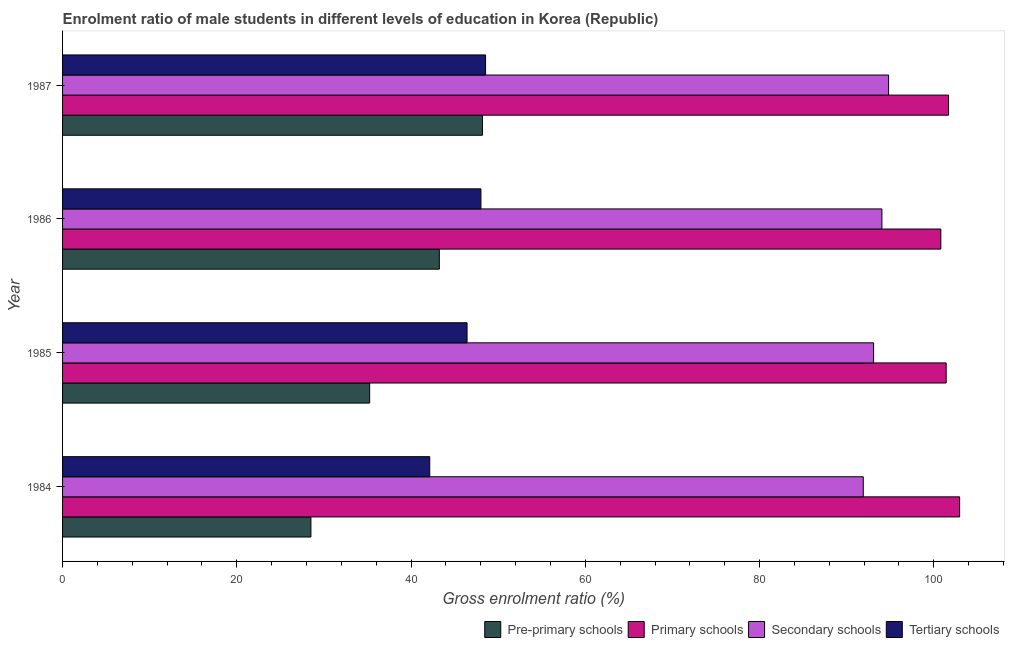How many groups of bars are there?
Give a very brief answer. 4. What is the gross enrolment ratio(female) in primary schools in 1984?
Provide a succinct answer. 102.97. Across all years, what is the maximum gross enrolment ratio(female) in secondary schools?
Provide a succinct answer. 94.81. Across all years, what is the minimum gross enrolment ratio(female) in secondary schools?
Your response must be concise. 91.91. In which year was the gross enrolment ratio(female) in tertiary schools maximum?
Give a very brief answer. 1987. What is the total gross enrolment ratio(female) in tertiary schools in the graph?
Provide a succinct answer. 185.15. What is the difference between the gross enrolment ratio(female) in secondary schools in 1985 and that in 1987?
Offer a very short reply. -1.72. What is the difference between the gross enrolment ratio(female) in primary schools in 1987 and the gross enrolment ratio(female) in secondary schools in 1984?
Your response must be concise. 9.79. What is the average gross enrolment ratio(female) in tertiary schools per year?
Give a very brief answer. 46.29. In the year 1984, what is the difference between the gross enrolment ratio(female) in primary schools and gross enrolment ratio(female) in tertiary schools?
Your answer should be very brief. 60.82. In how many years, is the gross enrolment ratio(female) in tertiary schools greater than 52 %?
Provide a short and direct response. 0. What is the ratio of the gross enrolment ratio(female) in pre-primary schools in 1985 to that in 1987?
Give a very brief answer. 0.73. Is the gross enrolment ratio(female) in pre-primary schools in 1984 less than that in 1987?
Give a very brief answer. Yes. What is the difference between the highest and the second highest gross enrolment ratio(female) in primary schools?
Your answer should be compact. 1.27. What is the difference between the highest and the lowest gross enrolment ratio(female) in primary schools?
Your answer should be compact. 2.16. In how many years, is the gross enrolment ratio(female) in pre-primary schools greater than the average gross enrolment ratio(female) in pre-primary schools taken over all years?
Offer a very short reply. 2. What does the 4th bar from the top in 1985 represents?
Make the answer very short. Pre-primary schools. What does the 2nd bar from the bottom in 1986 represents?
Keep it short and to the point. Primary schools. Is it the case that in every year, the sum of the gross enrolment ratio(female) in pre-primary schools and gross enrolment ratio(female) in primary schools is greater than the gross enrolment ratio(female) in secondary schools?
Ensure brevity in your answer.  Yes. How many bars are there?
Your answer should be very brief. 16. How many years are there in the graph?
Make the answer very short. 4. What is the difference between two consecutive major ticks on the X-axis?
Provide a succinct answer. 20. Are the values on the major ticks of X-axis written in scientific E-notation?
Offer a terse response. No. Does the graph contain any zero values?
Your answer should be compact. No. How many legend labels are there?
Ensure brevity in your answer.  4. What is the title of the graph?
Provide a succinct answer. Enrolment ratio of male students in different levels of education in Korea (Republic). What is the label or title of the Y-axis?
Your answer should be very brief. Year. What is the Gross enrolment ratio (%) of Pre-primary schools in 1984?
Provide a succinct answer. 28.51. What is the Gross enrolment ratio (%) in Primary schools in 1984?
Provide a succinct answer. 102.97. What is the Gross enrolment ratio (%) of Secondary schools in 1984?
Keep it short and to the point. 91.91. What is the Gross enrolment ratio (%) in Tertiary schools in 1984?
Your answer should be compact. 42.15. What is the Gross enrolment ratio (%) in Pre-primary schools in 1985?
Your response must be concise. 35.25. What is the Gross enrolment ratio (%) of Primary schools in 1985?
Keep it short and to the point. 101.42. What is the Gross enrolment ratio (%) of Secondary schools in 1985?
Your answer should be very brief. 93.09. What is the Gross enrolment ratio (%) of Tertiary schools in 1985?
Offer a terse response. 46.43. What is the Gross enrolment ratio (%) in Pre-primary schools in 1986?
Keep it short and to the point. 43.25. What is the Gross enrolment ratio (%) in Primary schools in 1986?
Give a very brief answer. 100.81. What is the Gross enrolment ratio (%) in Secondary schools in 1986?
Give a very brief answer. 94.04. What is the Gross enrolment ratio (%) of Tertiary schools in 1986?
Offer a terse response. 48.02. What is the Gross enrolment ratio (%) of Pre-primary schools in 1987?
Provide a short and direct response. 48.19. What is the Gross enrolment ratio (%) in Primary schools in 1987?
Your answer should be very brief. 101.69. What is the Gross enrolment ratio (%) of Secondary schools in 1987?
Keep it short and to the point. 94.81. What is the Gross enrolment ratio (%) in Tertiary schools in 1987?
Ensure brevity in your answer.  48.55. Across all years, what is the maximum Gross enrolment ratio (%) in Pre-primary schools?
Offer a terse response. 48.19. Across all years, what is the maximum Gross enrolment ratio (%) in Primary schools?
Your answer should be very brief. 102.97. Across all years, what is the maximum Gross enrolment ratio (%) of Secondary schools?
Ensure brevity in your answer.  94.81. Across all years, what is the maximum Gross enrolment ratio (%) in Tertiary schools?
Provide a succinct answer. 48.55. Across all years, what is the minimum Gross enrolment ratio (%) of Pre-primary schools?
Keep it short and to the point. 28.51. Across all years, what is the minimum Gross enrolment ratio (%) of Primary schools?
Keep it short and to the point. 100.81. Across all years, what is the minimum Gross enrolment ratio (%) in Secondary schools?
Provide a succinct answer. 91.91. Across all years, what is the minimum Gross enrolment ratio (%) in Tertiary schools?
Offer a terse response. 42.15. What is the total Gross enrolment ratio (%) in Pre-primary schools in the graph?
Provide a short and direct response. 155.2. What is the total Gross enrolment ratio (%) in Primary schools in the graph?
Keep it short and to the point. 406.89. What is the total Gross enrolment ratio (%) in Secondary schools in the graph?
Provide a short and direct response. 373.86. What is the total Gross enrolment ratio (%) of Tertiary schools in the graph?
Ensure brevity in your answer.  185.15. What is the difference between the Gross enrolment ratio (%) of Pre-primary schools in 1984 and that in 1985?
Provide a succinct answer. -6.74. What is the difference between the Gross enrolment ratio (%) in Primary schools in 1984 and that in 1985?
Your answer should be compact. 1.55. What is the difference between the Gross enrolment ratio (%) in Secondary schools in 1984 and that in 1985?
Your response must be concise. -1.19. What is the difference between the Gross enrolment ratio (%) of Tertiary schools in 1984 and that in 1985?
Give a very brief answer. -4.28. What is the difference between the Gross enrolment ratio (%) in Pre-primary schools in 1984 and that in 1986?
Offer a terse response. -14.74. What is the difference between the Gross enrolment ratio (%) of Primary schools in 1984 and that in 1986?
Your answer should be very brief. 2.16. What is the difference between the Gross enrolment ratio (%) in Secondary schools in 1984 and that in 1986?
Keep it short and to the point. -2.14. What is the difference between the Gross enrolment ratio (%) in Tertiary schools in 1984 and that in 1986?
Your response must be concise. -5.87. What is the difference between the Gross enrolment ratio (%) in Pre-primary schools in 1984 and that in 1987?
Ensure brevity in your answer.  -19.69. What is the difference between the Gross enrolment ratio (%) of Primary schools in 1984 and that in 1987?
Your response must be concise. 1.27. What is the difference between the Gross enrolment ratio (%) of Secondary schools in 1984 and that in 1987?
Your answer should be compact. -2.91. What is the difference between the Gross enrolment ratio (%) in Tertiary schools in 1984 and that in 1987?
Provide a succinct answer. -6.41. What is the difference between the Gross enrolment ratio (%) in Pre-primary schools in 1985 and that in 1986?
Your answer should be compact. -8. What is the difference between the Gross enrolment ratio (%) of Primary schools in 1985 and that in 1986?
Make the answer very short. 0.61. What is the difference between the Gross enrolment ratio (%) in Secondary schools in 1985 and that in 1986?
Your response must be concise. -0.95. What is the difference between the Gross enrolment ratio (%) of Tertiary schools in 1985 and that in 1986?
Make the answer very short. -1.59. What is the difference between the Gross enrolment ratio (%) in Pre-primary schools in 1985 and that in 1987?
Your answer should be very brief. -12.95. What is the difference between the Gross enrolment ratio (%) of Primary schools in 1985 and that in 1987?
Your answer should be very brief. -0.27. What is the difference between the Gross enrolment ratio (%) of Secondary schools in 1985 and that in 1987?
Ensure brevity in your answer.  -1.72. What is the difference between the Gross enrolment ratio (%) of Tertiary schools in 1985 and that in 1987?
Give a very brief answer. -2.12. What is the difference between the Gross enrolment ratio (%) of Pre-primary schools in 1986 and that in 1987?
Provide a short and direct response. -4.95. What is the difference between the Gross enrolment ratio (%) in Primary schools in 1986 and that in 1987?
Your response must be concise. -0.89. What is the difference between the Gross enrolment ratio (%) of Secondary schools in 1986 and that in 1987?
Give a very brief answer. -0.77. What is the difference between the Gross enrolment ratio (%) of Tertiary schools in 1986 and that in 1987?
Your answer should be very brief. -0.53. What is the difference between the Gross enrolment ratio (%) of Pre-primary schools in 1984 and the Gross enrolment ratio (%) of Primary schools in 1985?
Your answer should be compact. -72.91. What is the difference between the Gross enrolment ratio (%) in Pre-primary schools in 1984 and the Gross enrolment ratio (%) in Secondary schools in 1985?
Offer a terse response. -64.59. What is the difference between the Gross enrolment ratio (%) of Pre-primary schools in 1984 and the Gross enrolment ratio (%) of Tertiary schools in 1985?
Your answer should be compact. -17.92. What is the difference between the Gross enrolment ratio (%) of Primary schools in 1984 and the Gross enrolment ratio (%) of Secondary schools in 1985?
Give a very brief answer. 9.88. What is the difference between the Gross enrolment ratio (%) in Primary schools in 1984 and the Gross enrolment ratio (%) in Tertiary schools in 1985?
Your answer should be very brief. 56.54. What is the difference between the Gross enrolment ratio (%) of Secondary schools in 1984 and the Gross enrolment ratio (%) of Tertiary schools in 1985?
Make the answer very short. 45.48. What is the difference between the Gross enrolment ratio (%) in Pre-primary schools in 1984 and the Gross enrolment ratio (%) in Primary schools in 1986?
Your answer should be compact. -72.3. What is the difference between the Gross enrolment ratio (%) in Pre-primary schools in 1984 and the Gross enrolment ratio (%) in Secondary schools in 1986?
Keep it short and to the point. -65.54. What is the difference between the Gross enrolment ratio (%) of Pre-primary schools in 1984 and the Gross enrolment ratio (%) of Tertiary schools in 1986?
Provide a succinct answer. -19.51. What is the difference between the Gross enrolment ratio (%) of Primary schools in 1984 and the Gross enrolment ratio (%) of Secondary schools in 1986?
Your answer should be compact. 8.92. What is the difference between the Gross enrolment ratio (%) of Primary schools in 1984 and the Gross enrolment ratio (%) of Tertiary schools in 1986?
Offer a very short reply. 54.95. What is the difference between the Gross enrolment ratio (%) in Secondary schools in 1984 and the Gross enrolment ratio (%) in Tertiary schools in 1986?
Offer a very short reply. 43.89. What is the difference between the Gross enrolment ratio (%) in Pre-primary schools in 1984 and the Gross enrolment ratio (%) in Primary schools in 1987?
Provide a short and direct response. -73.19. What is the difference between the Gross enrolment ratio (%) in Pre-primary schools in 1984 and the Gross enrolment ratio (%) in Secondary schools in 1987?
Give a very brief answer. -66.31. What is the difference between the Gross enrolment ratio (%) in Pre-primary schools in 1984 and the Gross enrolment ratio (%) in Tertiary schools in 1987?
Make the answer very short. -20.05. What is the difference between the Gross enrolment ratio (%) of Primary schools in 1984 and the Gross enrolment ratio (%) of Secondary schools in 1987?
Your response must be concise. 8.15. What is the difference between the Gross enrolment ratio (%) of Primary schools in 1984 and the Gross enrolment ratio (%) of Tertiary schools in 1987?
Offer a very short reply. 54.41. What is the difference between the Gross enrolment ratio (%) in Secondary schools in 1984 and the Gross enrolment ratio (%) in Tertiary schools in 1987?
Offer a very short reply. 43.35. What is the difference between the Gross enrolment ratio (%) in Pre-primary schools in 1985 and the Gross enrolment ratio (%) in Primary schools in 1986?
Offer a very short reply. -65.56. What is the difference between the Gross enrolment ratio (%) of Pre-primary schools in 1985 and the Gross enrolment ratio (%) of Secondary schools in 1986?
Your answer should be compact. -58.8. What is the difference between the Gross enrolment ratio (%) of Pre-primary schools in 1985 and the Gross enrolment ratio (%) of Tertiary schools in 1986?
Offer a terse response. -12.77. What is the difference between the Gross enrolment ratio (%) in Primary schools in 1985 and the Gross enrolment ratio (%) in Secondary schools in 1986?
Keep it short and to the point. 7.38. What is the difference between the Gross enrolment ratio (%) of Primary schools in 1985 and the Gross enrolment ratio (%) of Tertiary schools in 1986?
Your answer should be very brief. 53.4. What is the difference between the Gross enrolment ratio (%) of Secondary schools in 1985 and the Gross enrolment ratio (%) of Tertiary schools in 1986?
Your answer should be compact. 45.07. What is the difference between the Gross enrolment ratio (%) of Pre-primary schools in 1985 and the Gross enrolment ratio (%) of Primary schools in 1987?
Your answer should be very brief. -66.44. What is the difference between the Gross enrolment ratio (%) in Pre-primary schools in 1985 and the Gross enrolment ratio (%) in Secondary schools in 1987?
Provide a short and direct response. -59.56. What is the difference between the Gross enrolment ratio (%) of Pre-primary schools in 1985 and the Gross enrolment ratio (%) of Tertiary schools in 1987?
Your answer should be compact. -13.3. What is the difference between the Gross enrolment ratio (%) of Primary schools in 1985 and the Gross enrolment ratio (%) of Secondary schools in 1987?
Keep it short and to the point. 6.61. What is the difference between the Gross enrolment ratio (%) in Primary schools in 1985 and the Gross enrolment ratio (%) in Tertiary schools in 1987?
Give a very brief answer. 52.87. What is the difference between the Gross enrolment ratio (%) of Secondary schools in 1985 and the Gross enrolment ratio (%) of Tertiary schools in 1987?
Your answer should be very brief. 44.54. What is the difference between the Gross enrolment ratio (%) in Pre-primary schools in 1986 and the Gross enrolment ratio (%) in Primary schools in 1987?
Your response must be concise. -58.45. What is the difference between the Gross enrolment ratio (%) of Pre-primary schools in 1986 and the Gross enrolment ratio (%) of Secondary schools in 1987?
Offer a terse response. -51.57. What is the difference between the Gross enrolment ratio (%) of Pre-primary schools in 1986 and the Gross enrolment ratio (%) of Tertiary schools in 1987?
Give a very brief answer. -5.31. What is the difference between the Gross enrolment ratio (%) in Primary schools in 1986 and the Gross enrolment ratio (%) in Secondary schools in 1987?
Ensure brevity in your answer.  6. What is the difference between the Gross enrolment ratio (%) in Primary schools in 1986 and the Gross enrolment ratio (%) in Tertiary schools in 1987?
Make the answer very short. 52.26. What is the difference between the Gross enrolment ratio (%) in Secondary schools in 1986 and the Gross enrolment ratio (%) in Tertiary schools in 1987?
Offer a very short reply. 45.49. What is the average Gross enrolment ratio (%) of Pre-primary schools per year?
Keep it short and to the point. 38.8. What is the average Gross enrolment ratio (%) of Primary schools per year?
Your answer should be compact. 101.72. What is the average Gross enrolment ratio (%) in Secondary schools per year?
Provide a succinct answer. 93.46. What is the average Gross enrolment ratio (%) in Tertiary schools per year?
Your answer should be very brief. 46.29. In the year 1984, what is the difference between the Gross enrolment ratio (%) in Pre-primary schools and Gross enrolment ratio (%) in Primary schools?
Give a very brief answer. -74.46. In the year 1984, what is the difference between the Gross enrolment ratio (%) of Pre-primary schools and Gross enrolment ratio (%) of Secondary schools?
Offer a very short reply. -63.4. In the year 1984, what is the difference between the Gross enrolment ratio (%) of Pre-primary schools and Gross enrolment ratio (%) of Tertiary schools?
Your response must be concise. -13.64. In the year 1984, what is the difference between the Gross enrolment ratio (%) of Primary schools and Gross enrolment ratio (%) of Secondary schools?
Your answer should be very brief. 11.06. In the year 1984, what is the difference between the Gross enrolment ratio (%) in Primary schools and Gross enrolment ratio (%) in Tertiary schools?
Make the answer very short. 60.82. In the year 1984, what is the difference between the Gross enrolment ratio (%) of Secondary schools and Gross enrolment ratio (%) of Tertiary schools?
Provide a succinct answer. 49.76. In the year 1985, what is the difference between the Gross enrolment ratio (%) in Pre-primary schools and Gross enrolment ratio (%) in Primary schools?
Offer a very short reply. -66.17. In the year 1985, what is the difference between the Gross enrolment ratio (%) of Pre-primary schools and Gross enrolment ratio (%) of Secondary schools?
Your answer should be compact. -57.84. In the year 1985, what is the difference between the Gross enrolment ratio (%) in Pre-primary schools and Gross enrolment ratio (%) in Tertiary schools?
Give a very brief answer. -11.18. In the year 1985, what is the difference between the Gross enrolment ratio (%) in Primary schools and Gross enrolment ratio (%) in Secondary schools?
Offer a terse response. 8.33. In the year 1985, what is the difference between the Gross enrolment ratio (%) in Primary schools and Gross enrolment ratio (%) in Tertiary schools?
Offer a terse response. 54.99. In the year 1985, what is the difference between the Gross enrolment ratio (%) in Secondary schools and Gross enrolment ratio (%) in Tertiary schools?
Your response must be concise. 46.66. In the year 1986, what is the difference between the Gross enrolment ratio (%) of Pre-primary schools and Gross enrolment ratio (%) of Primary schools?
Give a very brief answer. -57.56. In the year 1986, what is the difference between the Gross enrolment ratio (%) in Pre-primary schools and Gross enrolment ratio (%) in Secondary schools?
Your response must be concise. -50.8. In the year 1986, what is the difference between the Gross enrolment ratio (%) of Pre-primary schools and Gross enrolment ratio (%) of Tertiary schools?
Ensure brevity in your answer.  -4.77. In the year 1986, what is the difference between the Gross enrolment ratio (%) of Primary schools and Gross enrolment ratio (%) of Secondary schools?
Offer a terse response. 6.76. In the year 1986, what is the difference between the Gross enrolment ratio (%) of Primary schools and Gross enrolment ratio (%) of Tertiary schools?
Provide a short and direct response. 52.79. In the year 1986, what is the difference between the Gross enrolment ratio (%) of Secondary schools and Gross enrolment ratio (%) of Tertiary schools?
Make the answer very short. 46.03. In the year 1987, what is the difference between the Gross enrolment ratio (%) in Pre-primary schools and Gross enrolment ratio (%) in Primary schools?
Your answer should be compact. -53.5. In the year 1987, what is the difference between the Gross enrolment ratio (%) of Pre-primary schools and Gross enrolment ratio (%) of Secondary schools?
Give a very brief answer. -46.62. In the year 1987, what is the difference between the Gross enrolment ratio (%) in Pre-primary schools and Gross enrolment ratio (%) in Tertiary schools?
Offer a terse response. -0.36. In the year 1987, what is the difference between the Gross enrolment ratio (%) in Primary schools and Gross enrolment ratio (%) in Secondary schools?
Your answer should be very brief. 6.88. In the year 1987, what is the difference between the Gross enrolment ratio (%) in Primary schools and Gross enrolment ratio (%) in Tertiary schools?
Offer a very short reply. 53.14. In the year 1987, what is the difference between the Gross enrolment ratio (%) in Secondary schools and Gross enrolment ratio (%) in Tertiary schools?
Your response must be concise. 46.26. What is the ratio of the Gross enrolment ratio (%) in Pre-primary schools in 1984 to that in 1985?
Your answer should be very brief. 0.81. What is the ratio of the Gross enrolment ratio (%) of Primary schools in 1984 to that in 1985?
Provide a short and direct response. 1.02. What is the ratio of the Gross enrolment ratio (%) in Secondary schools in 1984 to that in 1985?
Make the answer very short. 0.99. What is the ratio of the Gross enrolment ratio (%) of Tertiary schools in 1984 to that in 1985?
Offer a very short reply. 0.91. What is the ratio of the Gross enrolment ratio (%) of Pre-primary schools in 1984 to that in 1986?
Your answer should be compact. 0.66. What is the ratio of the Gross enrolment ratio (%) in Primary schools in 1984 to that in 1986?
Your response must be concise. 1.02. What is the ratio of the Gross enrolment ratio (%) in Secondary schools in 1984 to that in 1986?
Provide a succinct answer. 0.98. What is the ratio of the Gross enrolment ratio (%) in Tertiary schools in 1984 to that in 1986?
Give a very brief answer. 0.88. What is the ratio of the Gross enrolment ratio (%) in Pre-primary schools in 1984 to that in 1987?
Give a very brief answer. 0.59. What is the ratio of the Gross enrolment ratio (%) of Primary schools in 1984 to that in 1987?
Offer a very short reply. 1.01. What is the ratio of the Gross enrolment ratio (%) of Secondary schools in 1984 to that in 1987?
Offer a terse response. 0.97. What is the ratio of the Gross enrolment ratio (%) of Tertiary schools in 1984 to that in 1987?
Provide a short and direct response. 0.87. What is the ratio of the Gross enrolment ratio (%) in Pre-primary schools in 1985 to that in 1986?
Ensure brevity in your answer.  0.82. What is the ratio of the Gross enrolment ratio (%) of Primary schools in 1985 to that in 1986?
Offer a terse response. 1.01. What is the ratio of the Gross enrolment ratio (%) in Tertiary schools in 1985 to that in 1986?
Your response must be concise. 0.97. What is the ratio of the Gross enrolment ratio (%) in Pre-primary schools in 1985 to that in 1987?
Provide a succinct answer. 0.73. What is the ratio of the Gross enrolment ratio (%) of Primary schools in 1985 to that in 1987?
Give a very brief answer. 1. What is the ratio of the Gross enrolment ratio (%) in Secondary schools in 1985 to that in 1987?
Your answer should be compact. 0.98. What is the ratio of the Gross enrolment ratio (%) of Tertiary schools in 1985 to that in 1987?
Your answer should be compact. 0.96. What is the ratio of the Gross enrolment ratio (%) in Pre-primary schools in 1986 to that in 1987?
Your response must be concise. 0.9. What is the difference between the highest and the second highest Gross enrolment ratio (%) of Pre-primary schools?
Offer a very short reply. 4.95. What is the difference between the highest and the second highest Gross enrolment ratio (%) in Primary schools?
Your response must be concise. 1.27. What is the difference between the highest and the second highest Gross enrolment ratio (%) in Secondary schools?
Provide a succinct answer. 0.77. What is the difference between the highest and the second highest Gross enrolment ratio (%) in Tertiary schools?
Give a very brief answer. 0.53. What is the difference between the highest and the lowest Gross enrolment ratio (%) of Pre-primary schools?
Your answer should be very brief. 19.69. What is the difference between the highest and the lowest Gross enrolment ratio (%) in Primary schools?
Offer a terse response. 2.16. What is the difference between the highest and the lowest Gross enrolment ratio (%) in Secondary schools?
Give a very brief answer. 2.91. What is the difference between the highest and the lowest Gross enrolment ratio (%) in Tertiary schools?
Offer a very short reply. 6.41. 